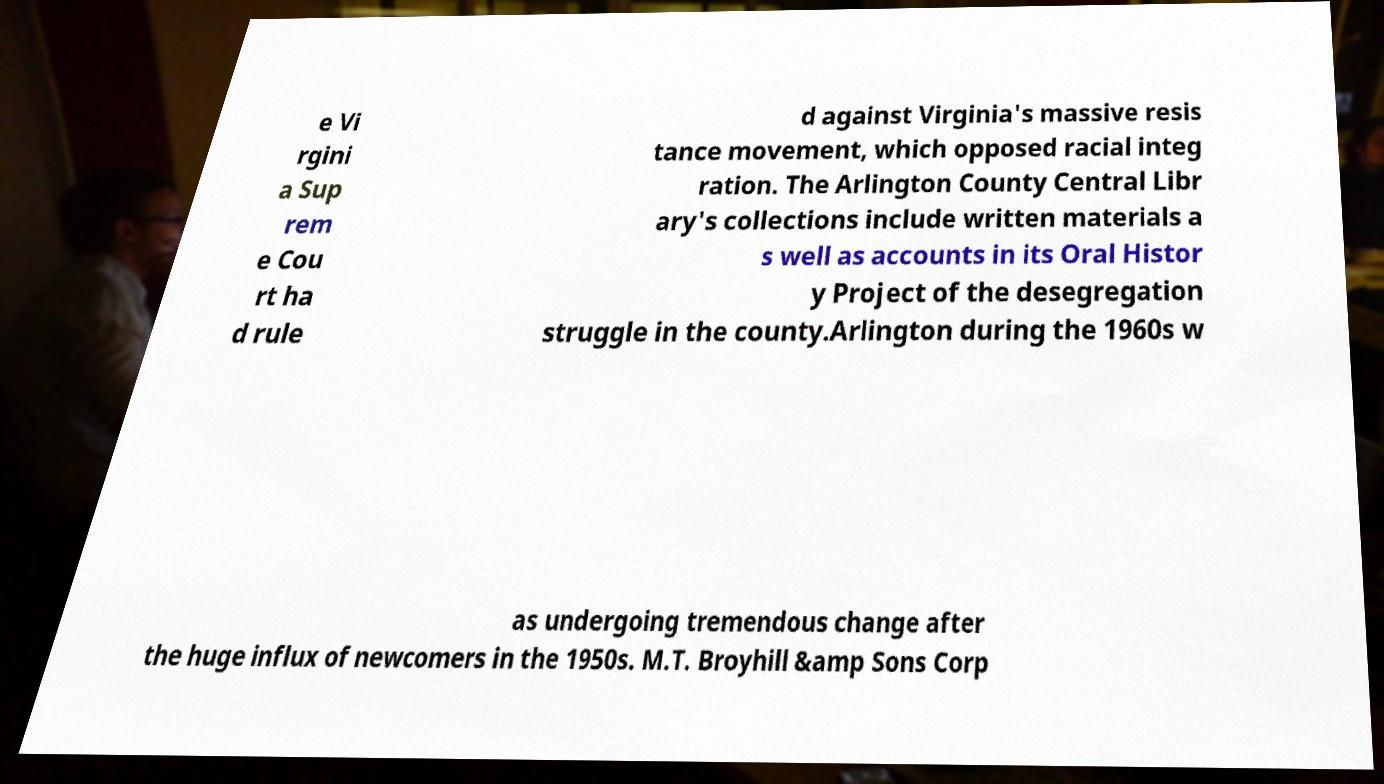What messages or text are displayed in this image? I need them in a readable, typed format. e Vi rgini a Sup rem e Cou rt ha d rule d against Virginia's massive resis tance movement, which opposed racial integ ration. The Arlington County Central Libr ary's collections include written materials a s well as accounts in its Oral Histor y Project of the desegregation struggle in the county.Arlington during the 1960s w as undergoing tremendous change after the huge influx of newcomers in the 1950s. M.T. Broyhill &amp Sons Corp 